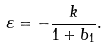Convert formula to latex. <formula><loc_0><loc_0><loc_500><loc_500>\varepsilon = - \frac { k } { 1 + b _ { 1 } } .</formula> 